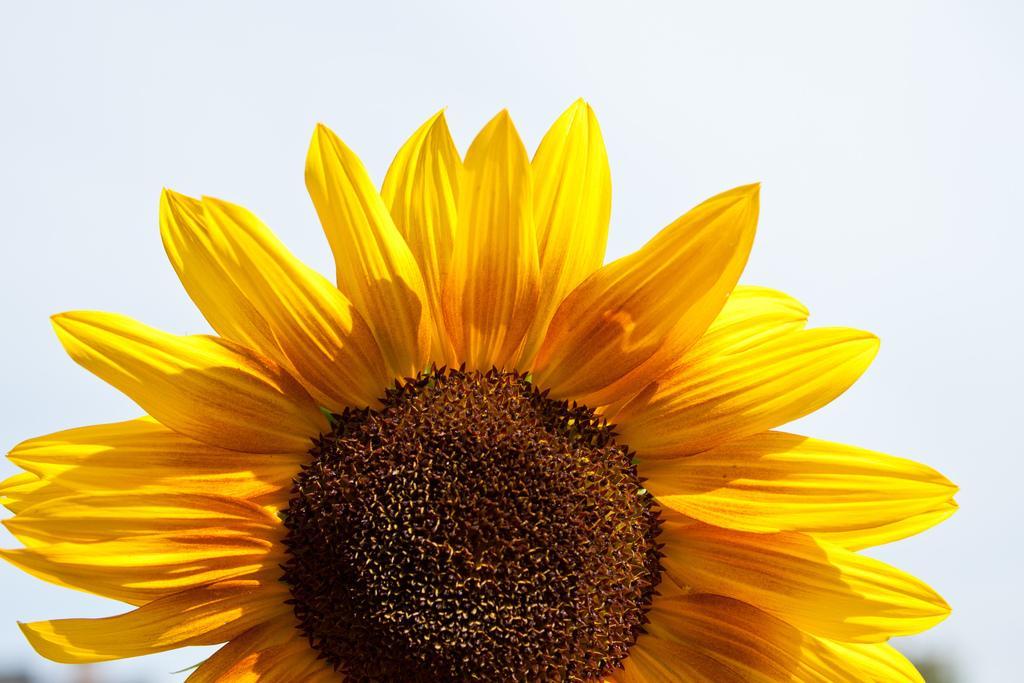Describe this image in one or two sentences. In this image we can see a flower. Behind the flower we can see the sky. 